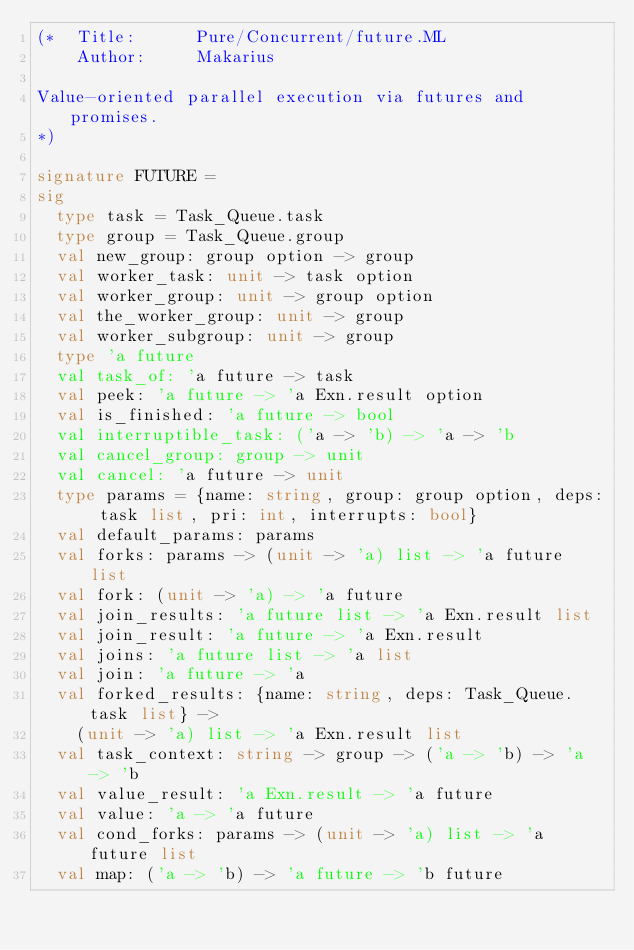<code> <loc_0><loc_0><loc_500><loc_500><_SML_>(*  Title:      Pure/Concurrent/future.ML
    Author:     Makarius

Value-oriented parallel execution via futures and promises.
*)

signature FUTURE =
sig
  type task = Task_Queue.task
  type group = Task_Queue.group
  val new_group: group option -> group
  val worker_task: unit -> task option
  val worker_group: unit -> group option
  val the_worker_group: unit -> group
  val worker_subgroup: unit -> group
  type 'a future
  val task_of: 'a future -> task
  val peek: 'a future -> 'a Exn.result option
  val is_finished: 'a future -> bool
  val interruptible_task: ('a -> 'b) -> 'a -> 'b
  val cancel_group: group -> unit
  val cancel: 'a future -> unit
  type params = {name: string, group: group option, deps: task list, pri: int, interrupts: bool}
  val default_params: params
  val forks: params -> (unit -> 'a) list -> 'a future list
  val fork: (unit -> 'a) -> 'a future
  val join_results: 'a future list -> 'a Exn.result list
  val join_result: 'a future -> 'a Exn.result
  val joins: 'a future list -> 'a list
  val join: 'a future -> 'a
  val forked_results: {name: string, deps: Task_Queue.task list} ->
    (unit -> 'a) list -> 'a Exn.result list
  val task_context: string -> group -> ('a -> 'b) -> 'a -> 'b
  val value_result: 'a Exn.result -> 'a future
  val value: 'a -> 'a future
  val cond_forks: params -> (unit -> 'a) list -> 'a future list
  val map: ('a -> 'b) -> 'a future -> 'b future</code> 